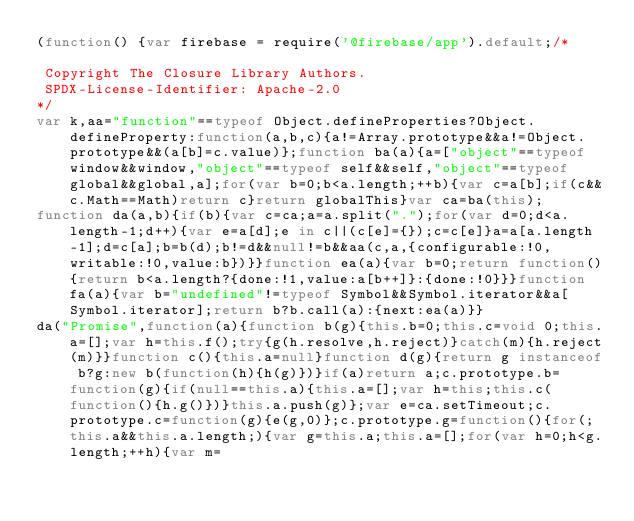Convert code to text. <code><loc_0><loc_0><loc_500><loc_500><_JavaScript_>(function() {var firebase = require('@firebase/app').default;/*

 Copyright The Closure Library Authors.
 SPDX-License-Identifier: Apache-2.0
*/
var k,aa="function"==typeof Object.defineProperties?Object.defineProperty:function(a,b,c){a!=Array.prototype&&a!=Object.prototype&&(a[b]=c.value)};function ba(a){a=["object"==typeof window&&window,"object"==typeof self&&self,"object"==typeof global&&global,a];for(var b=0;b<a.length;++b){var c=a[b];if(c&&c.Math==Math)return c}return globalThis}var ca=ba(this);
function da(a,b){if(b){var c=ca;a=a.split(".");for(var d=0;d<a.length-1;d++){var e=a[d];e in c||(c[e]={});c=c[e]}a=a[a.length-1];d=c[a];b=b(d);b!=d&&null!=b&&aa(c,a,{configurable:!0,writable:!0,value:b})}}function ea(a){var b=0;return function(){return b<a.length?{done:!1,value:a[b++]}:{done:!0}}}function fa(a){var b="undefined"!=typeof Symbol&&Symbol.iterator&&a[Symbol.iterator];return b?b.call(a):{next:ea(a)}}
da("Promise",function(a){function b(g){this.b=0;this.c=void 0;this.a=[];var h=this.f();try{g(h.resolve,h.reject)}catch(m){h.reject(m)}}function c(){this.a=null}function d(g){return g instanceof b?g:new b(function(h){h(g)})}if(a)return a;c.prototype.b=function(g){if(null==this.a){this.a=[];var h=this;this.c(function(){h.g()})}this.a.push(g)};var e=ca.setTimeout;c.prototype.c=function(g){e(g,0)};c.prototype.g=function(){for(;this.a&&this.a.length;){var g=this.a;this.a=[];for(var h=0;h<g.length;++h){var m=</code> 